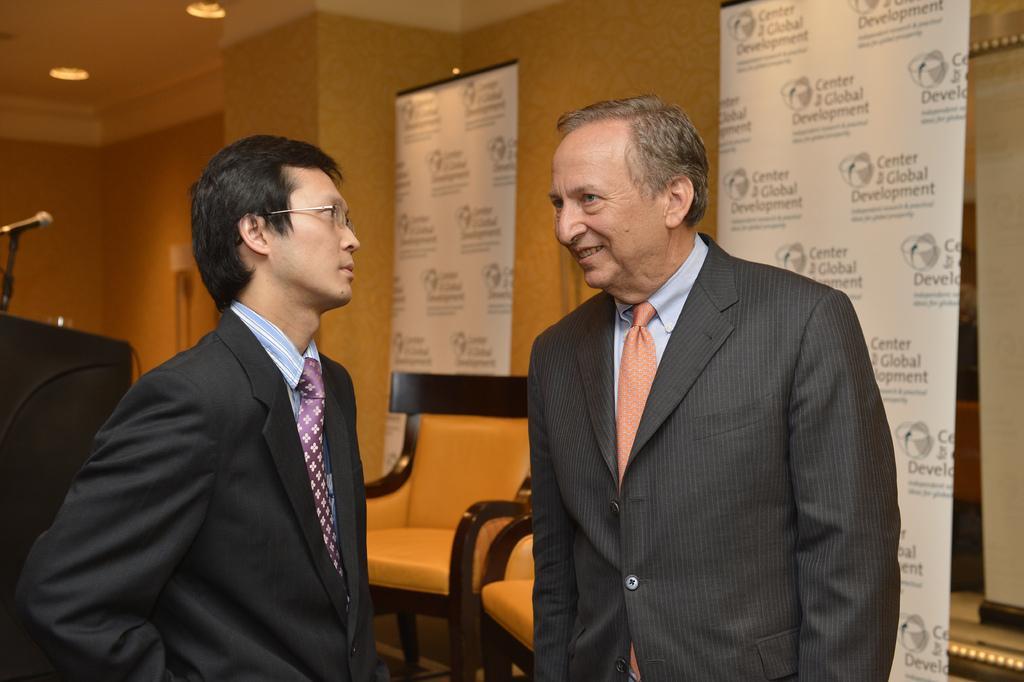Can you describe this image briefly? There are two men standing. In the background there are chairs and hoardings,wall and light. 